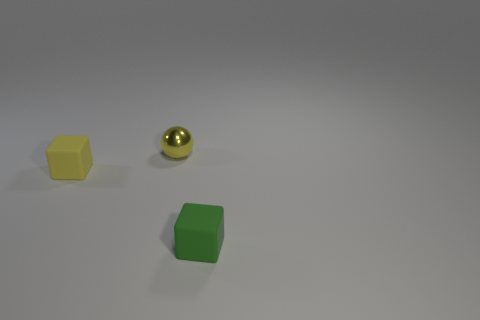Add 3 yellow objects. How many objects exist? 6 Subtract all spheres. How many objects are left? 2 Add 1 green rubber cubes. How many green rubber cubes are left? 2 Add 3 shiny balls. How many shiny balls exist? 4 Subtract 1 yellow balls. How many objects are left? 2 Subtract all tiny objects. Subtract all big yellow metal blocks. How many objects are left? 0 